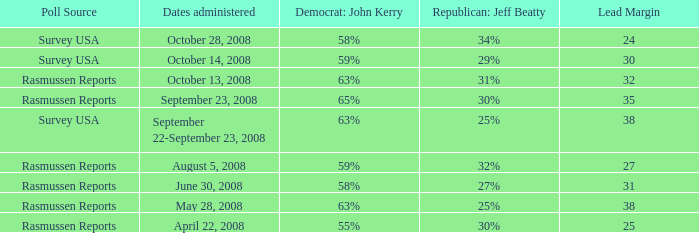What is hte date where republican jeaff beatty is 34%? October 28, 2008. 